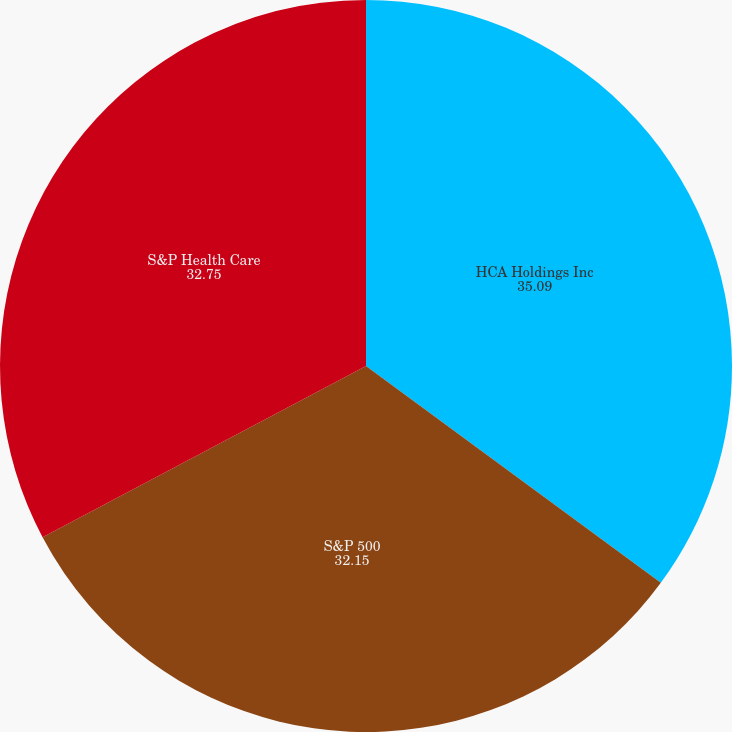Convert chart to OTSL. <chart><loc_0><loc_0><loc_500><loc_500><pie_chart><fcel>HCA Holdings Inc<fcel>S&P 500<fcel>S&P Health Care<nl><fcel>35.09%<fcel>32.15%<fcel>32.75%<nl></chart> 